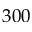Convert formula to latex. <formula><loc_0><loc_0><loc_500><loc_500>3 0 0</formula> 